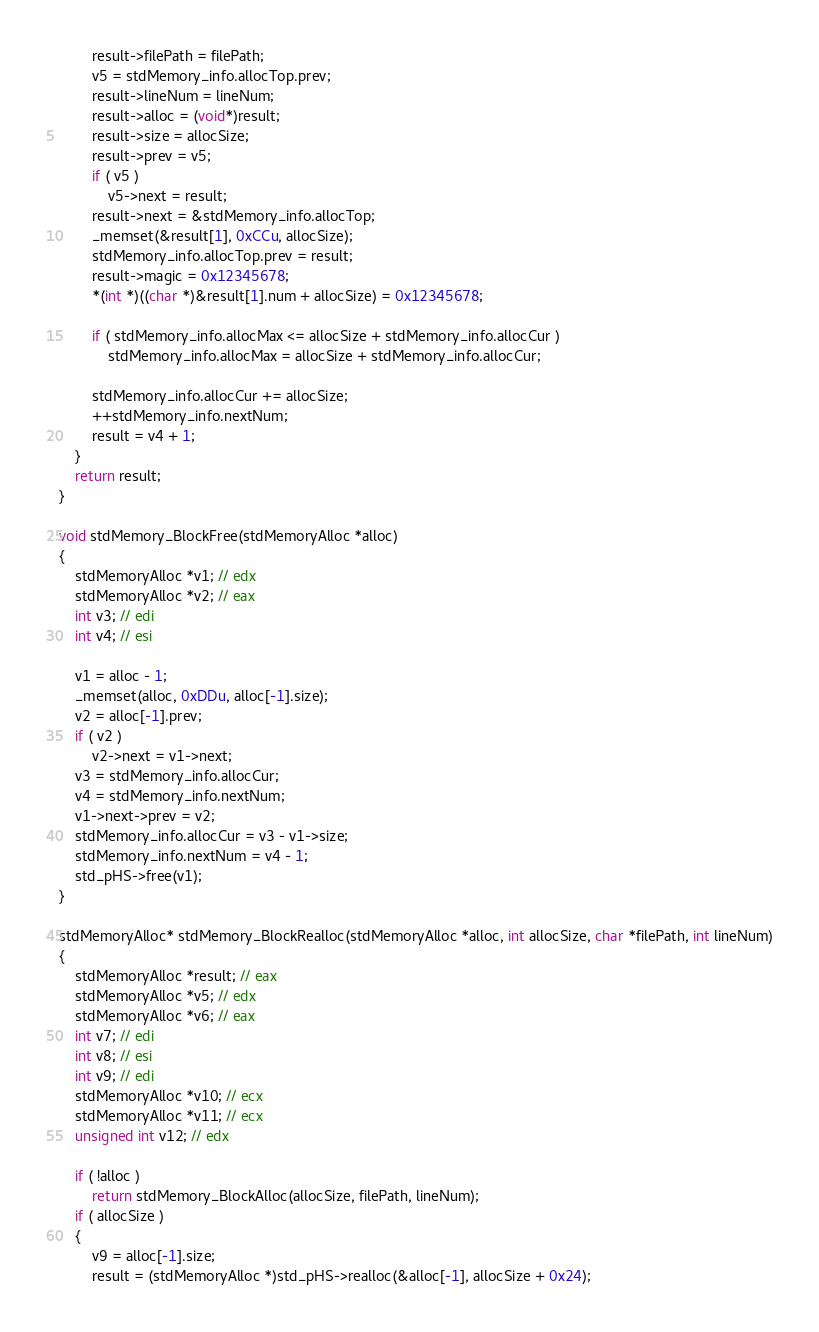Convert code to text. <code><loc_0><loc_0><loc_500><loc_500><_C_>        result->filePath = filePath;
        v5 = stdMemory_info.allocTop.prev;
        result->lineNum = lineNum;
        result->alloc = (void*)result;
        result->size = allocSize;
        result->prev = v5;
        if ( v5 )
            v5->next = result;
        result->next = &stdMemory_info.allocTop;
        _memset(&result[1], 0xCCu, allocSize);
        stdMemory_info.allocTop.prev = result;
        result->magic = 0x12345678;
        *(int *)((char *)&result[1].num + allocSize) = 0x12345678;

        if ( stdMemory_info.allocMax <= allocSize + stdMemory_info.allocCur )
            stdMemory_info.allocMax = allocSize + stdMemory_info.allocCur;

        stdMemory_info.allocCur += allocSize;
        ++stdMemory_info.nextNum;
        result = v4 + 1;
    }
    return result;
}

void stdMemory_BlockFree(stdMemoryAlloc *alloc)
{
    stdMemoryAlloc *v1; // edx
    stdMemoryAlloc *v2; // eax
    int v3; // edi
    int v4; // esi

    v1 = alloc - 1;
    _memset(alloc, 0xDDu, alloc[-1].size);
    v2 = alloc[-1].prev;
    if ( v2 )
        v2->next = v1->next;
    v3 = stdMemory_info.allocCur;
    v4 = stdMemory_info.nextNum;
    v1->next->prev = v2;
    stdMemory_info.allocCur = v3 - v1->size;
    stdMemory_info.nextNum = v4 - 1;
    std_pHS->free(v1);
}

stdMemoryAlloc* stdMemory_BlockRealloc(stdMemoryAlloc *alloc, int allocSize, char *filePath, int lineNum)
{
    stdMemoryAlloc *result; // eax
    stdMemoryAlloc *v5; // edx
    stdMemoryAlloc *v6; // eax
    int v7; // edi
    int v8; // esi
    int v9; // edi
    stdMemoryAlloc *v10; // ecx
    stdMemoryAlloc *v11; // ecx
    unsigned int v12; // edx

    if ( !alloc )
        return stdMemory_BlockAlloc(allocSize, filePath, lineNum);
    if ( allocSize )
    {
        v9 = alloc[-1].size;
        result = (stdMemoryAlloc *)std_pHS->realloc(&alloc[-1], allocSize + 0x24);</code> 